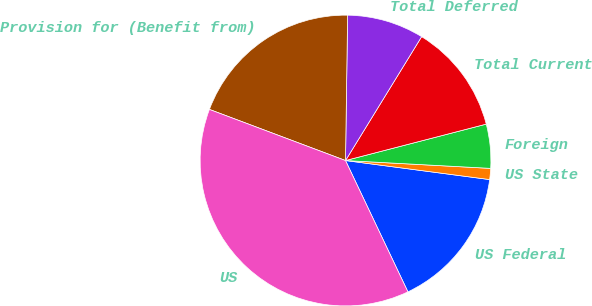<chart> <loc_0><loc_0><loc_500><loc_500><pie_chart><fcel>US Federal<fcel>US State<fcel>Foreign<fcel>Total Current<fcel>Total Deferred<fcel>Provision for (Benefit from)<fcel>US<nl><fcel>15.85%<fcel>1.23%<fcel>4.89%<fcel>12.2%<fcel>8.54%<fcel>19.51%<fcel>37.78%<nl></chart> 